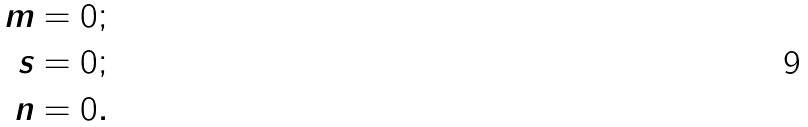<formula> <loc_0><loc_0><loc_500><loc_500>m & = 0 ; \\ s & = 0 ; \\ n & = 0 .</formula> 